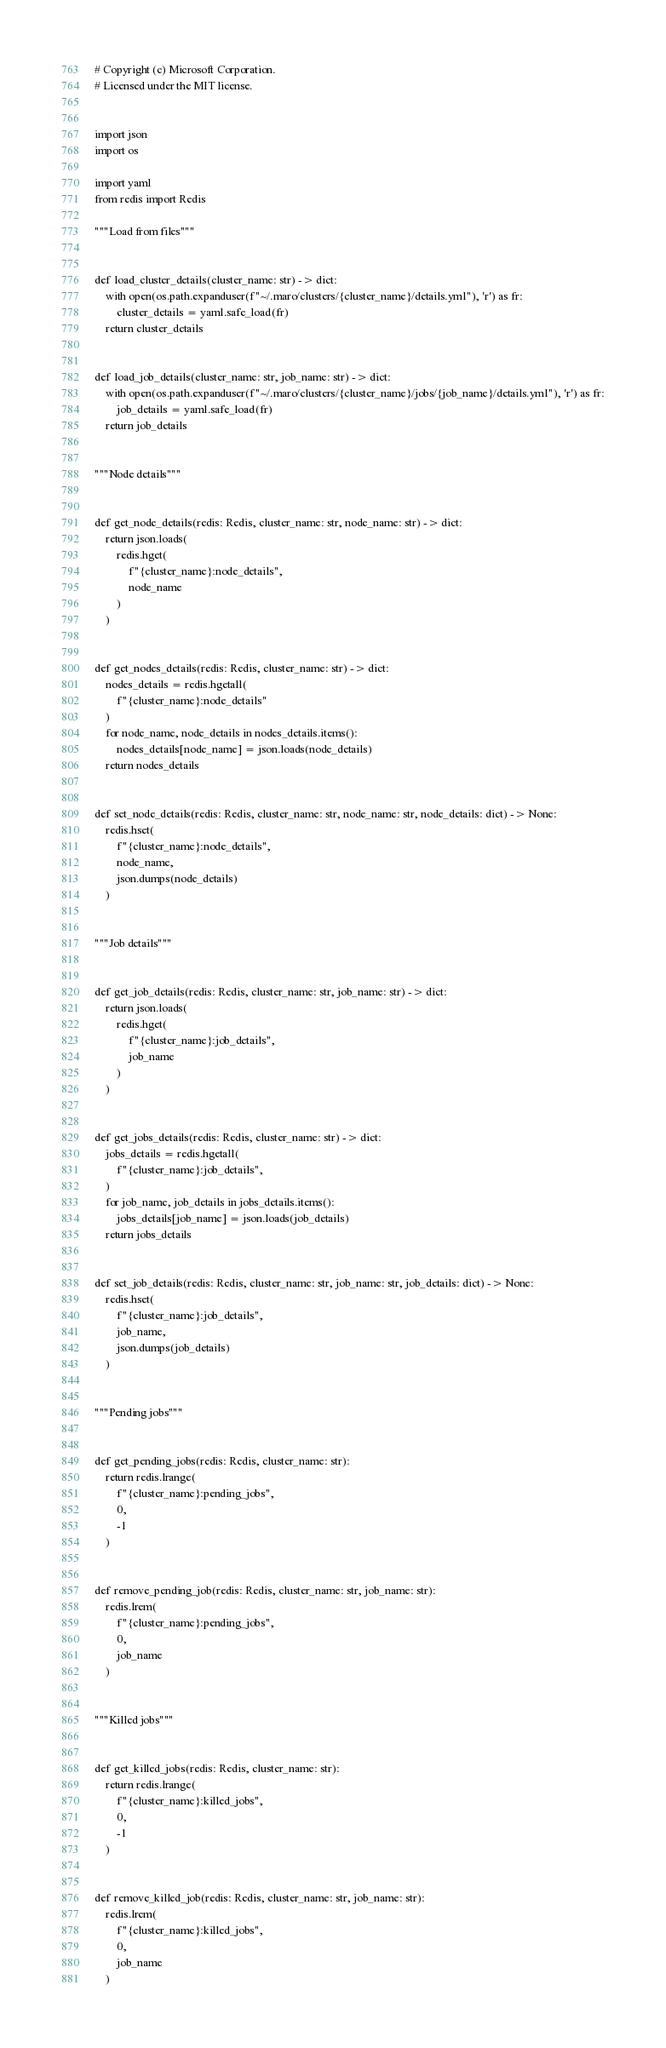Convert code to text. <code><loc_0><loc_0><loc_500><loc_500><_Python_># Copyright (c) Microsoft Corporation.
# Licensed under the MIT license.


import json
import os

import yaml
from redis import Redis

"""Load from files"""


def load_cluster_details(cluster_name: str) -> dict:
    with open(os.path.expanduser(f"~/.maro/clusters/{cluster_name}/details.yml"), 'r') as fr:
        cluster_details = yaml.safe_load(fr)
    return cluster_details


def load_job_details(cluster_name: str, job_name: str) -> dict:
    with open(os.path.expanduser(f"~/.maro/clusters/{cluster_name}/jobs/{job_name}/details.yml"), 'r') as fr:
        job_details = yaml.safe_load(fr)
    return job_details


"""Node details"""


def get_node_details(redis: Redis, cluster_name: str, node_name: str) -> dict:
    return json.loads(
        redis.hget(
            f"{cluster_name}:node_details",
            node_name
        )
    )


def get_nodes_details(redis: Redis, cluster_name: str) -> dict:
    nodes_details = redis.hgetall(
        f"{cluster_name}:node_details"
    )
    for node_name, node_details in nodes_details.items():
        nodes_details[node_name] = json.loads(node_details)
    return nodes_details


def set_node_details(redis: Redis, cluster_name: str, node_name: str, node_details: dict) -> None:
    redis.hset(
        f"{cluster_name}:node_details",
        node_name,
        json.dumps(node_details)
    )


"""Job details"""


def get_job_details(redis: Redis, cluster_name: str, job_name: str) -> dict:
    return json.loads(
        redis.hget(
            f"{cluster_name}:job_details",
            job_name
        )
    )


def get_jobs_details(redis: Redis, cluster_name: str) -> dict:
    jobs_details = redis.hgetall(
        f"{cluster_name}:job_details",
    )
    for job_name, job_details in jobs_details.items():
        jobs_details[job_name] = json.loads(job_details)
    return jobs_details


def set_job_details(redis: Redis, cluster_name: str, job_name: str, job_details: dict) -> None:
    redis.hset(
        f"{cluster_name}:job_details",
        job_name,
        json.dumps(job_details)
    )


"""Pending jobs"""


def get_pending_jobs(redis: Redis, cluster_name: str):
    return redis.lrange(
        f"{cluster_name}:pending_jobs",
        0,
        -1
    )


def remove_pending_job(redis: Redis, cluster_name: str, job_name: str):
    redis.lrem(
        f"{cluster_name}:pending_jobs",
        0,
        job_name
    )


"""Killed jobs"""


def get_killed_jobs(redis: Redis, cluster_name: str):
    return redis.lrange(
        f"{cluster_name}:killed_jobs",
        0,
        -1
    )


def remove_killed_job(redis: Redis, cluster_name: str, job_name: str):
    redis.lrem(
        f"{cluster_name}:killed_jobs",
        0,
        job_name
    )
</code> 